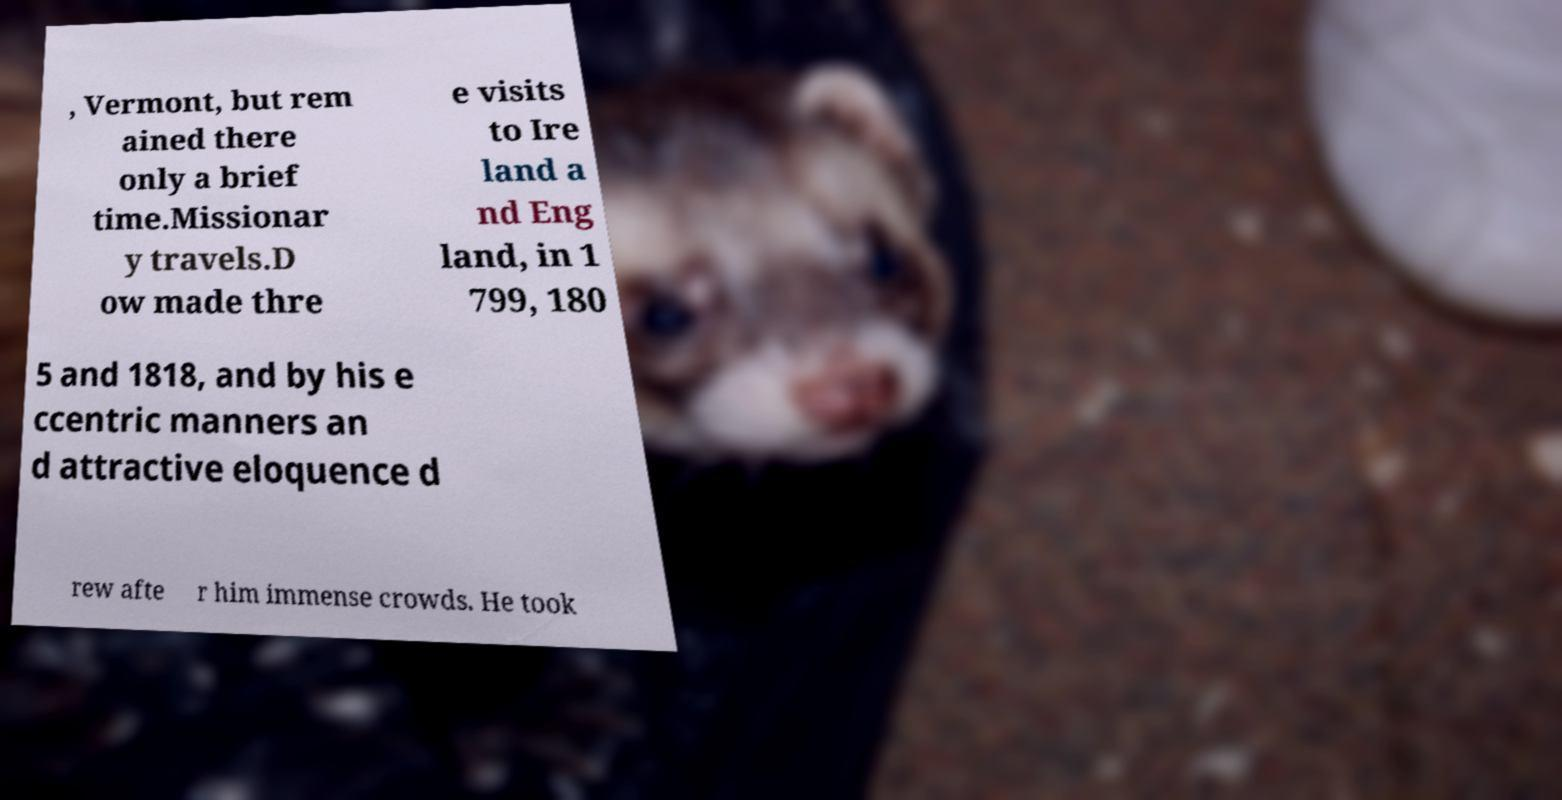I need the written content from this picture converted into text. Can you do that? , Vermont, but rem ained there only a brief time.Missionar y travels.D ow made thre e visits to Ire land a nd Eng land, in 1 799, 180 5 and 1818, and by his e ccentric manners an d attractive eloquence d rew afte r him immense crowds. He took 